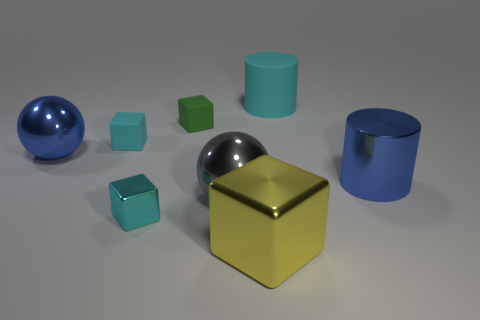Subtract all small green cubes. How many cubes are left? 3 Add 1 big green metallic cubes. How many objects exist? 9 Subtract all yellow blocks. How many blocks are left? 3 Subtract all purple cubes. How many brown spheres are left? 0 Subtract all green rubber cubes. Subtract all large shiny spheres. How many objects are left? 5 Add 3 tiny objects. How many tiny objects are left? 6 Add 7 big green blocks. How many big green blocks exist? 7 Subtract 1 yellow cubes. How many objects are left? 7 Subtract all balls. How many objects are left? 6 Subtract 1 cylinders. How many cylinders are left? 1 